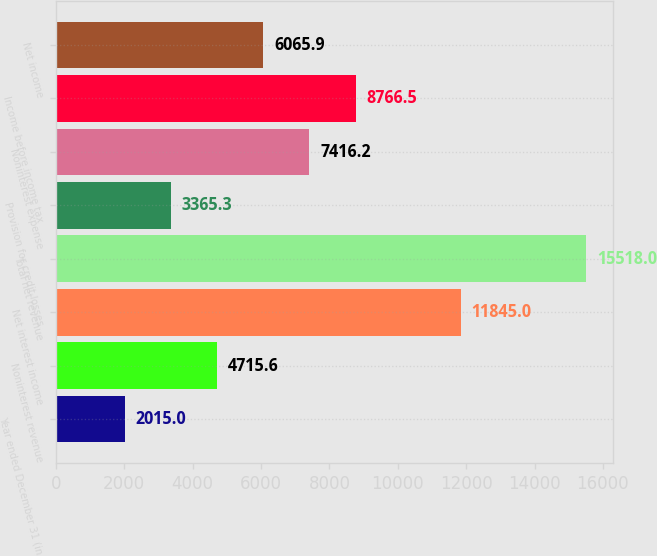<chart> <loc_0><loc_0><loc_500><loc_500><bar_chart><fcel>Year ended December 31 (in<fcel>Noninterest revenue<fcel>Net interest income<fcel>Total net revenue<fcel>Provision for credit losses<fcel>Noninterest expense<fcel>Income before income tax<fcel>Net income<nl><fcel>2015<fcel>4715.6<fcel>11845<fcel>15518<fcel>3365.3<fcel>7416.2<fcel>8766.5<fcel>6065.9<nl></chart> 